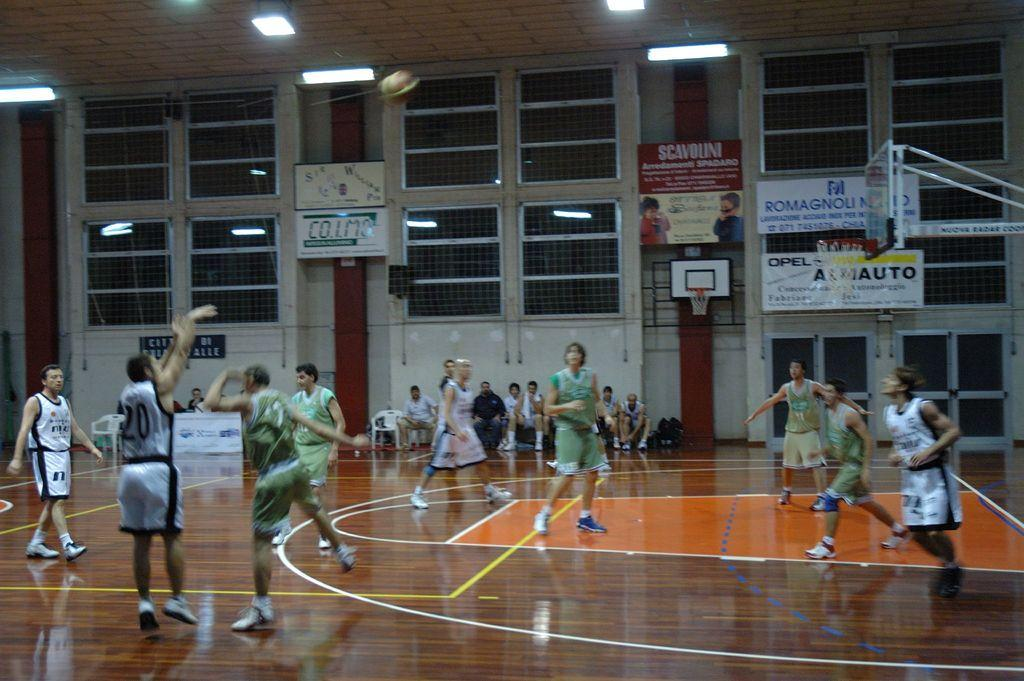<image>
Provide a brief description of the given image. A basketball game is in progress on a court sponsored by Romagnoli and Opel, while number 20 shoots the ball. 